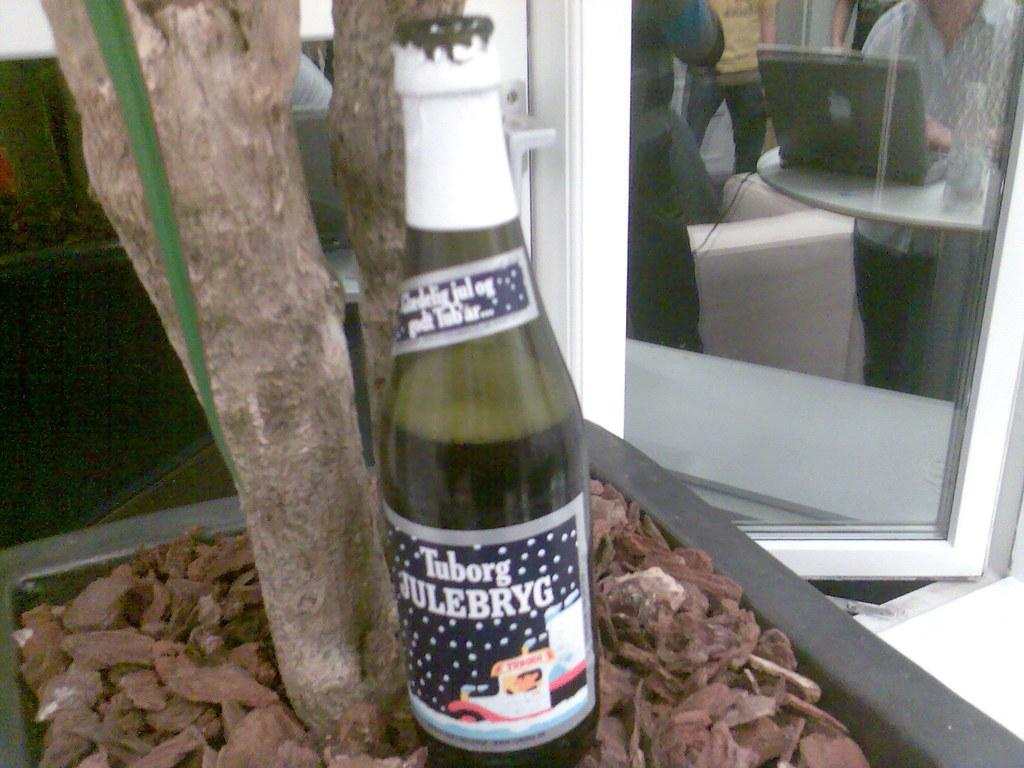What can be seen in the image that is related to a beverage? There is a beer bottle in the image. Where is the beer bottle placed? The beer bottle is on a clay pot. What type of architectural feature is present in the image? There is a glass window in the image. What is the man visible in the glass window doing? The man is working on a laptop. On what surface is the laptop placed? The laptop is on a table. What is the level of pollution visible outside the glass window in the image? There is no information about the level of pollution in the image; it only shows a man working on a laptop through a glass window. 